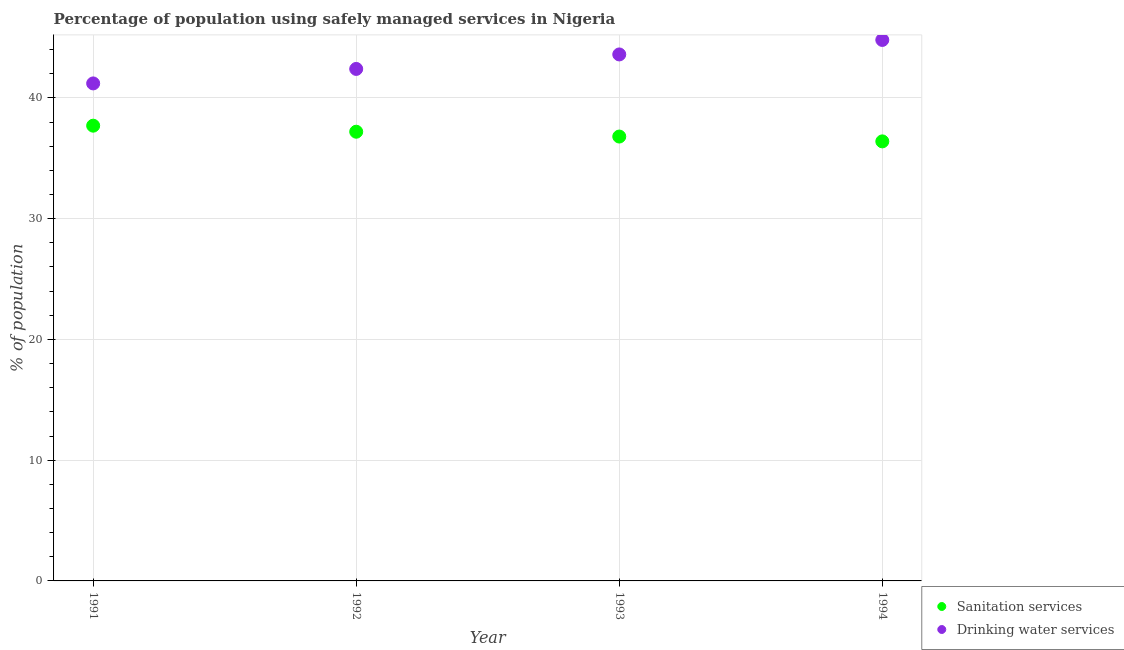How many different coloured dotlines are there?
Your answer should be compact. 2. Is the number of dotlines equal to the number of legend labels?
Offer a very short reply. Yes. What is the percentage of population who used drinking water services in 1992?
Your response must be concise. 42.4. Across all years, what is the maximum percentage of population who used drinking water services?
Provide a short and direct response. 44.8. Across all years, what is the minimum percentage of population who used drinking water services?
Keep it short and to the point. 41.2. What is the total percentage of population who used sanitation services in the graph?
Provide a succinct answer. 148.1. What is the difference between the percentage of population who used drinking water services in 1993 and that in 1994?
Provide a succinct answer. -1.2. What is the average percentage of population who used sanitation services per year?
Ensure brevity in your answer.  37.02. In the year 1993, what is the difference between the percentage of population who used drinking water services and percentage of population who used sanitation services?
Give a very brief answer. 6.8. What is the ratio of the percentage of population who used sanitation services in 1991 to that in 1992?
Ensure brevity in your answer.  1.01. Is the difference between the percentage of population who used drinking water services in 1993 and 1994 greater than the difference between the percentage of population who used sanitation services in 1993 and 1994?
Provide a succinct answer. No. What is the difference between the highest and the second highest percentage of population who used sanitation services?
Ensure brevity in your answer.  0.5. What is the difference between the highest and the lowest percentage of population who used drinking water services?
Keep it short and to the point. 3.6. In how many years, is the percentage of population who used sanitation services greater than the average percentage of population who used sanitation services taken over all years?
Keep it short and to the point. 2. Is the percentage of population who used drinking water services strictly greater than the percentage of population who used sanitation services over the years?
Your response must be concise. Yes. Is the percentage of population who used sanitation services strictly less than the percentage of population who used drinking water services over the years?
Ensure brevity in your answer.  Yes. How many years are there in the graph?
Your response must be concise. 4. What is the difference between two consecutive major ticks on the Y-axis?
Ensure brevity in your answer.  10. Are the values on the major ticks of Y-axis written in scientific E-notation?
Your response must be concise. No. Does the graph contain grids?
Keep it short and to the point. Yes. How are the legend labels stacked?
Offer a terse response. Vertical. What is the title of the graph?
Ensure brevity in your answer.  Percentage of population using safely managed services in Nigeria. What is the label or title of the Y-axis?
Your answer should be compact. % of population. What is the % of population of Sanitation services in 1991?
Give a very brief answer. 37.7. What is the % of population of Drinking water services in 1991?
Ensure brevity in your answer.  41.2. What is the % of population in Sanitation services in 1992?
Offer a terse response. 37.2. What is the % of population of Drinking water services in 1992?
Keep it short and to the point. 42.4. What is the % of population in Sanitation services in 1993?
Make the answer very short. 36.8. What is the % of population of Drinking water services in 1993?
Provide a succinct answer. 43.6. What is the % of population of Sanitation services in 1994?
Your answer should be very brief. 36.4. What is the % of population in Drinking water services in 1994?
Make the answer very short. 44.8. Across all years, what is the maximum % of population of Sanitation services?
Offer a terse response. 37.7. Across all years, what is the maximum % of population of Drinking water services?
Your answer should be compact. 44.8. Across all years, what is the minimum % of population in Sanitation services?
Make the answer very short. 36.4. Across all years, what is the minimum % of population in Drinking water services?
Your answer should be very brief. 41.2. What is the total % of population in Sanitation services in the graph?
Your answer should be compact. 148.1. What is the total % of population in Drinking water services in the graph?
Your answer should be compact. 172. What is the difference between the % of population of Sanitation services in 1991 and that in 1992?
Make the answer very short. 0.5. What is the difference between the % of population in Drinking water services in 1991 and that in 1992?
Ensure brevity in your answer.  -1.2. What is the difference between the % of population in Sanitation services in 1991 and that in 1993?
Ensure brevity in your answer.  0.9. What is the difference between the % of population in Sanitation services in 1991 and that in 1994?
Ensure brevity in your answer.  1.3. What is the difference between the % of population of Drinking water services in 1991 and that in 1994?
Give a very brief answer. -3.6. What is the difference between the % of population of Sanitation services in 1992 and that in 1993?
Provide a short and direct response. 0.4. What is the difference between the % of population of Drinking water services in 1992 and that in 1993?
Keep it short and to the point. -1.2. What is the difference between the % of population in Drinking water services in 1992 and that in 1994?
Provide a short and direct response. -2.4. What is the difference between the % of population in Drinking water services in 1993 and that in 1994?
Ensure brevity in your answer.  -1.2. What is the difference between the % of population of Sanitation services in 1991 and the % of population of Drinking water services in 1994?
Provide a succinct answer. -7.1. What is the difference between the % of population in Sanitation services in 1992 and the % of population in Drinking water services in 1993?
Provide a short and direct response. -6.4. What is the difference between the % of population of Sanitation services in 1992 and the % of population of Drinking water services in 1994?
Keep it short and to the point. -7.6. What is the average % of population of Sanitation services per year?
Keep it short and to the point. 37.02. In the year 1991, what is the difference between the % of population of Sanitation services and % of population of Drinking water services?
Make the answer very short. -3.5. In the year 1992, what is the difference between the % of population in Sanitation services and % of population in Drinking water services?
Offer a terse response. -5.2. What is the ratio of the % of population of Sanitation services in 1991 to that in 1992?
Your answer should be compact. 1.01. What is the ratio of the % of population in Drinking water services in 1991 to that in 1992?
Make the answer very short. 0.97. What is the ratio of the % of population in Sanitation services in 1991 to that in 1993?
Give a very brief answer. 1.02. What is the ratio of the % of population in Drinking water services in 1991 to that in 1993?
Keep it short and to the point. 0.94. What is the ratio of the % of population of Sanitation services in 1991 to that in 1994?
Give a very brief answer. 1.04. What is the ratio of the % of population of Drinking water services in 1991 to that in 1994?
Ensure brevity in your answer.  0.92. What is the ratio of the % of population of Sanitation services in 1992 to that in 1993?
Give a very brief answer. 1.01. What is the ratio of the % of population in Drinking water services in 1992 to that in 1993?
Offer a terse response. 0.97. What is the ratio of the % of population in Drinking water services in 1992 to that in 1994?
Keep it short and to the point. 0.95. What is the ratio of the % of population of Sanitation services in 1993 to that in 1994?
Your answer should be compact. 1.01. What is the ratio of the % of population in Drinking water services in 1993 to that in 1994?
Keep it short and to the point. 0.97. What is the difference between the highest and the second highest % of population of Sanitation services?
Your answer should be very brief. 0.5. What is the difference between the highest and the second highest % of population of Drinking water services?
Make the answer very short. 1.2. What is the difference between the highest and the lowest % of population of Sanitation services?
Make the answer very short. 1.3. 